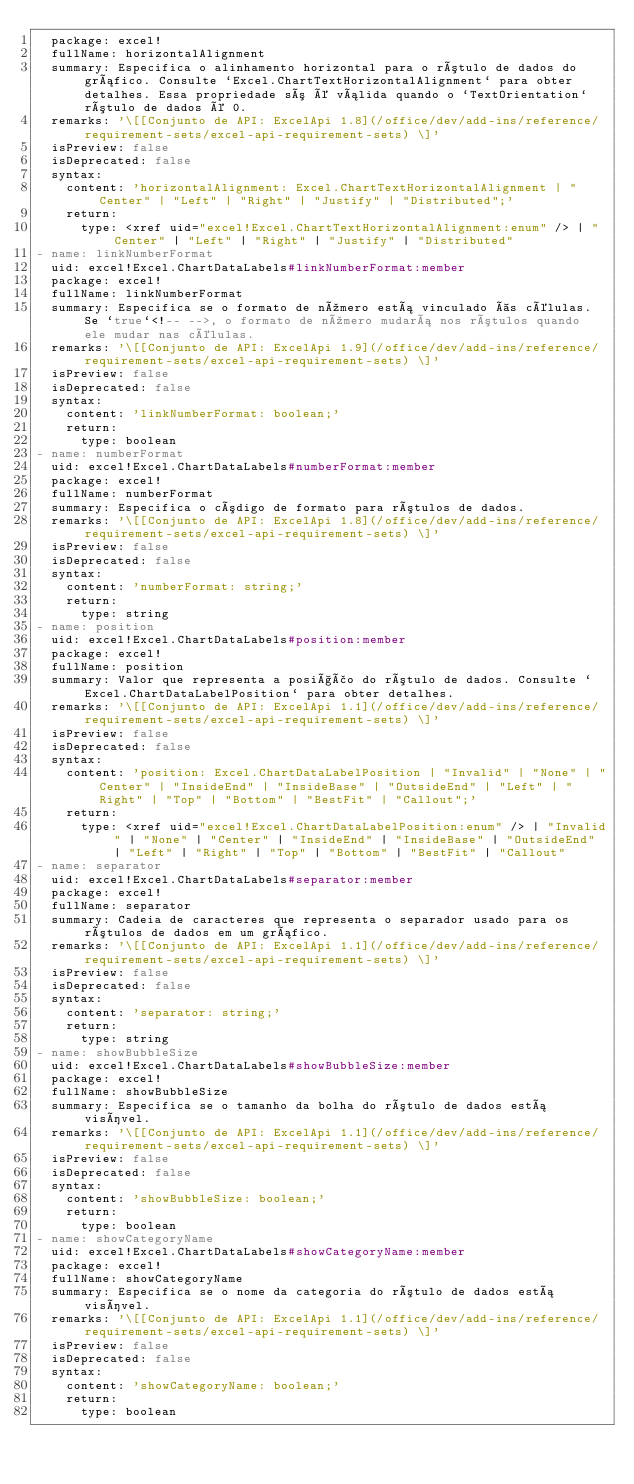<code> <loc_0><loc_0><loc_500><loc_500><_YAML_>  package: excel!
  fullName: horizontalAlignment
  summary: Especifica o alinhamento horizontal para o rótulo de dados do gráfico. Consulte `Excel.ChartTextHorizontalAlignment` para obter detalhes. Essa propriedade só é válida quando o `TextOrientation` rótulo de dados é 0.
  remarks: '\[[Conjunto de API: ExcelApi 1.8](/office/dev/add-ins/reference/requirement-sets/excel-api-requirement-sets) \]'
  isPreview: false
  isDeprecated: false
  syntax:
    content: 'horizontalAlignment: Excel.ChartTextHorizontalAlignment | "Center" | "Left" | "Right" | "Justify" | "Distributed";'
    return:
      type: <xref uid="excel!Excel.ChartTextHorizontalAlignment:enum" /> | "Center" | "Left" | "Right" | "Justify" | "Distributed"
- name: linkNumberFormat
  uid: excel!Excel.ChartDataLabels#linkNumberFormat:member
  package: excel!
  fullName: linkNumberFormat
  summary: Especifica se o formato de número está vinculado às células. Se `true`<!-- -->, o formato de número mudará nos rótulos quando ele mudar nas células.
  remarks: '\[[Conjunto de API: ExcelApi 1.9](/office/dev/add-ins/reference/requirement-sets/excel-api-requirement-sets) \]'
  isPreview: false
  isDeprecated: false
  syntax:
    content: 'linkNumberFormat: boolean;'
    return:
      type: boolean
- name: numberFormat
  uid: excel!Excel.ChartDataLabels#numberFormat:member
  package: excel!
  fullName: numberFormat
  summary: Especifica o código de formato para rótulos de dados.
  remarks: '\[[Conjunto de API: ExcelApi 1.8](/office/dev/add-ins/reference/requirement-sets/excel-api-requirement-sets) \]'
  isPreview: false
  isDeprecated: false
  syntax:
    content: 'numberFormat: string;'
    return:
      type: string
- name: position
  uid: excel!Excel.ChartDataLabels#position:member
  package: excel!
  fullName: position
  summary: Valor que representa a posição do rótulo de dados. Consulte `Excel.ChartDataLabelPosition` para obter detalhes.
  remarks: '\[[Conjunto de API: ExcelApi 1.1](/office/dev/add-ins/reference/requirement-sets/excel-api-requirement-sets) \]'
  isPreview: false
  isDeprecated: false
  syntax:
    content: 'position: Excel.ChartDataLabelPosition | "Invalid" | "None" | "Center" | "InsideEnd" | "InsideBase" | "OutsideEnd" | "Left" | "Right" | "Top" | "Bottom" | "BestFit" | "Callout";'
    return:
      type: <xref uid="excel!Excel.ChartDataLabelPosition:enum" /> | "Invalid" | "None" | "Center" | "InsideEnd" | "InsideBase" | "OutsideEnd" | "Left" | "Right" | "Top" | "Bottom" | "BestFit" | "Callout"
- name: separator
  uid: excel!Excel.ChartDataLabels#separator:member
  package: excel!
  fullName: separator
  summary: Cadeia de caracteres que representa o separador usado para os rótulos de dados em um gráfico.
  remarks: '\[[Conjunto de API: ExcelApi 1.1](/office/dev/add-ins/reference/requirement-sets/excel-api-requirement-sets) \]'
  isPreview: false
  isDeprecated: false
  syntax:
    content: 'separator: string;'
    return:
      type: string
- name: showBubbleSize
  uid: excel!Excel.ChartDataLabels#showBubbleSize:member
  package: excel!
  fullName: showBubbleSize
  summary: Especifica se o tamanho da bolha do rótulo de dados está visível.
  remarks: '\[[Conjunto de API: ExcelApi 1.1](/office/dev/add-ins/reference/requirement-sets/excel-api-requirement-sets) \]'
  isPreview: false
  isDeprecated: false
  syntax:
    content: 'showBubbleSize: boolean;'
    return:
      type: boolean
- name: showCategoryName
  uid: excel!Excel.ChartDataLabels#showCategoryName:member
  package: excel!
  fullName: showCategoryName
  summary: Especifica se o nome da categoria do rótulo de dados está visível.
  remarks: '\[[Conjunto de API: ExcelApi 1.1](/office/dev/add-ins/reference/requirement-sets/excel-api-requirement-sets) \]'
  isPreview: false
  isDeprecated: false
  syntax:
    content: 'showCategoryName: boolean;'
    return:
      type: boolean</code> 